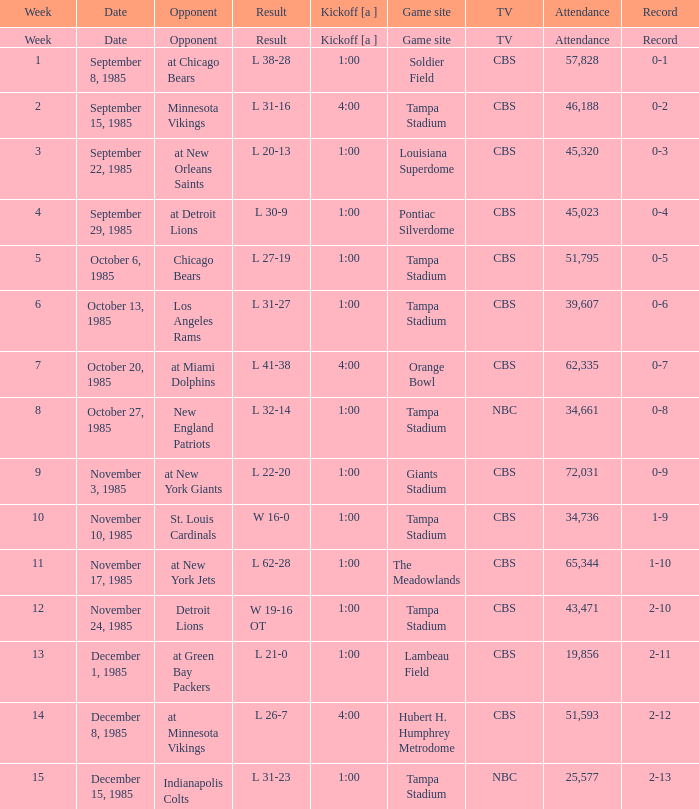Discover all the product(s) with the documentation of 2-1 L 31-23. 